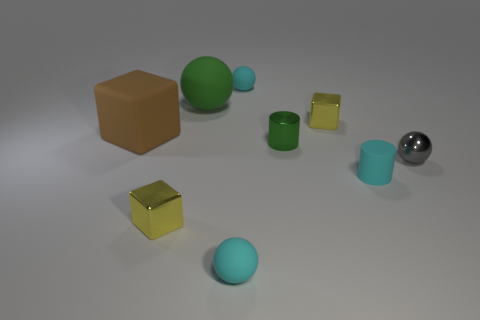What is the color of the small matte cylinder that is on the right side of the small object in front of the small metal object in front of the gray metallic ball?
Offer a very short reply. Cyan. Does the large green ball have the same material as the cyan cylinder?
Offer a very short reply. Yes. What number of blue objects are tiny matte objects or spheres?
Give a very brief answer. 0. There is a gray ball; how many gray spheres are behind it?
Offer a very short reply. 0. Is the number of big green things greater than the number of small yellow rubber blocks?
Offer a very short reply. Yes. The tiny yellow shiny object on the right side of the small matte thing that is behind the big cube is what shape?
Offer a very short reply. Cube. Does the metallic cylinder have the same color as the large matte sphere?
Provide a short and direct response. Yes. Are there more small things behind the gray metal ball than yellow rubber balls?
Make the answer very short. Yes. There is a yellow object behind the shiny cylinder; what number of tiny yellow metallic objects are behind it?
Offer a very short reply. 0. Is the material of the tiny gray object that is right of the green shiny object the same as the cyan ball that is in front of the small green metal thing?
Keep it short and to the point. No. 